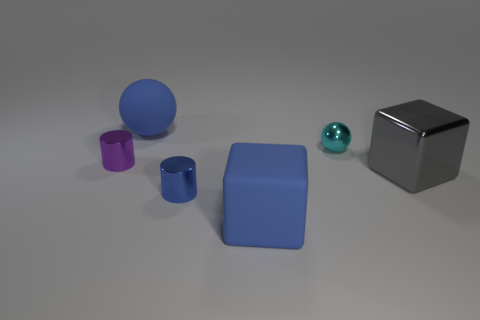What number of objects are either large brown blocks or metal cylinders?
Ensure brevity in your answer.  2. Do the purple object and the matte thing that is in front of the matte sphere have the same size?
Offer a terse response. No. How big is the cube that is behind the cube in front of the large gray metallic cube that is in front of the small purple metallic object?
Keep it short and to the point. Large. Are there any brown cylinders?
Give a very brief answer. No. There is a small thing that is the same color as the big rubber ball; what material is it?
Provide a short and direct response. Metal. How many large metallic cubes have the same color as the big matte ball?
Give a very brief answer. 0. What number of objects are big objects that are in front of the tiny shiny ball or gray shiny objects right of the tiny purple thing?
Your answer should be very brief. 2. There is a shiny cube that is in front of the purple object; what number of cylinders are behind it?
Keep it short and to the point. 1. What is the color of the tiny cylinder that is the same material as the tiny purple object?
Your response must be concise. Blue. Are there any green matte things that have the same size as the shiny ball?
Provide a succinct answer. No. 